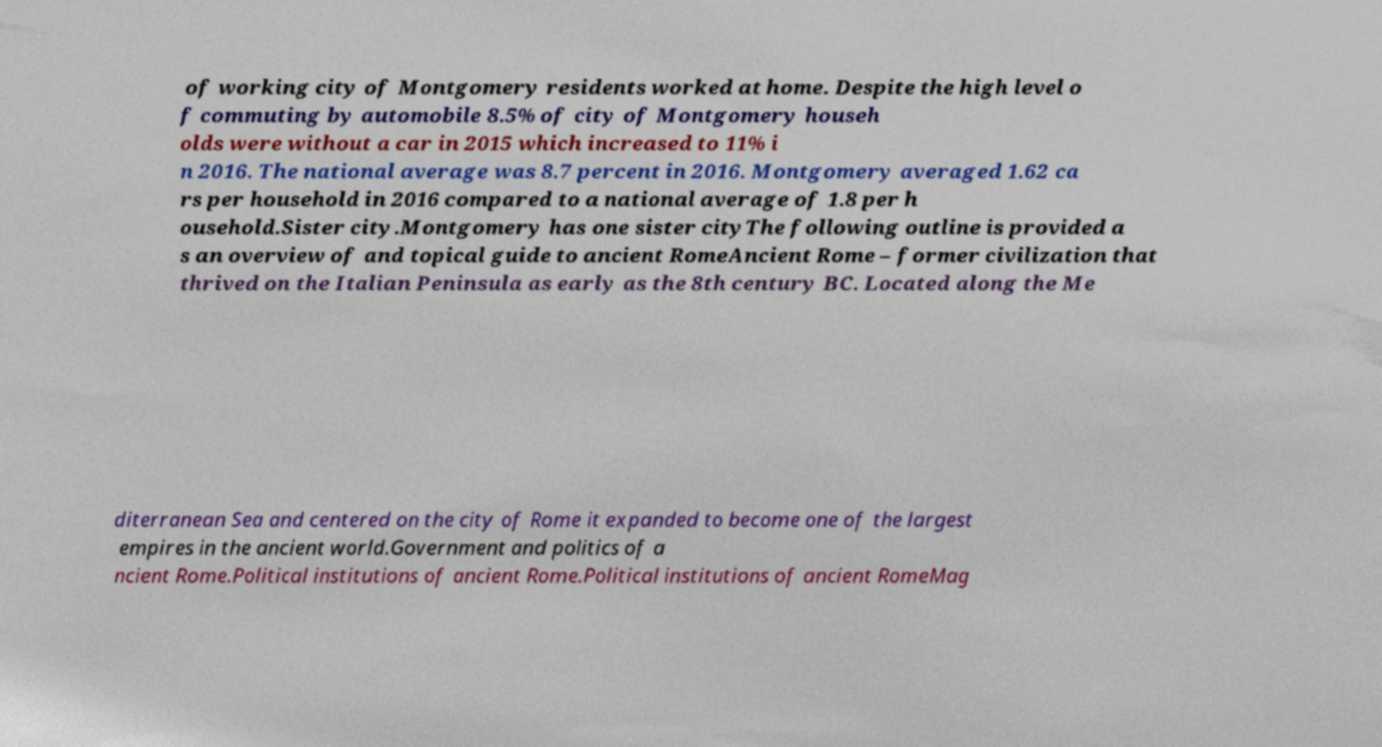What messages or text are displayed in this image? I need them in a readable, typed format. of working city of Montgomery residents worked at home. Despite the high level o f commuting by automobile 8.5% of city of Montgomery househ olds were without a car in 2015 which increased to 11% i n 2016. The national average was 8.7 percent in 2016. Montgomery averaged 1.62 ca rs per household in 2016 compared to a national average of 1.8 per h ousehold.Sister city.Montgomery has one sister cityThe following outline is provided a s an overview of and topical guide to ancient RomeAncient Rome – former civilization that thrived on the Italian Peninsula as early as the 8th century BC. Located along the Me diterranean Sea and centered on the city of Rome it expanded to become one of the largest empires in the ancient world.Government and politics of a ncient Rome.Political institutions of ancient Rome.Political institutions of ancient RomeMag 